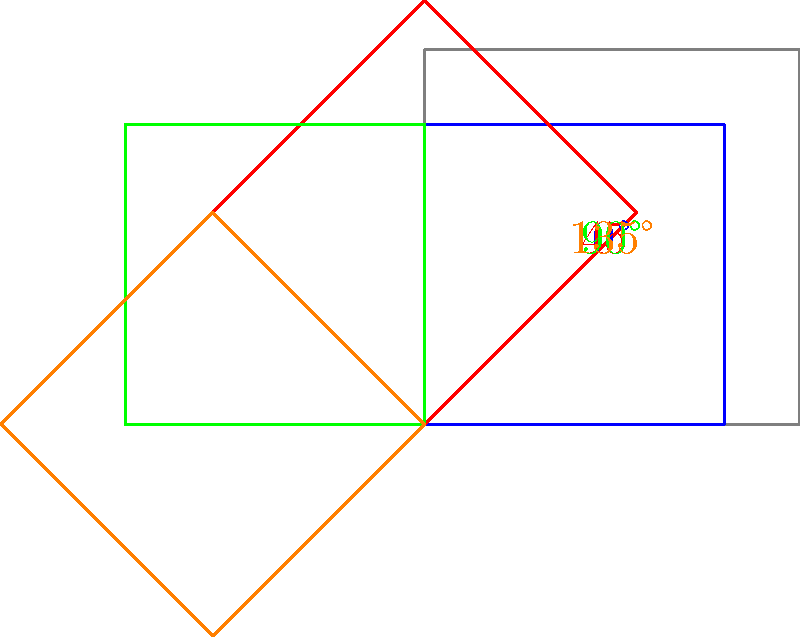You're designing a loading animation for your startup's new mobile app. The animation involves rotating the app icon by different angles. If the icon starts at 0° and rotates counterclockwise, what is the total rotation angle needed to create a smooth animation sequence that includes the positions shown in the diagram (blue, red, green, and orange)? To determine the total rotation angle, we need to follow these steps:

1. Identify the rotation angles for each position:
   - Blue icon: 0° (starting position)
   - Red icon: 45°
   - Green icon: 90°
   - Orange icon: 135°

2. Calculate the difference between the largest and smallest angles:
   $135° - 0° = 135°$

3. However, for a smooth animation, we need to complete a full rotation back to the starting position. This means we need to add the remaining angle to reach 360°:

   $360° - 135° = 225°$

4. Add this remaining angle to our previous calculation:
   $135° + 225° = 360°$

Therefore, the total rotation angle needed for a smooth animation sequence that includes all shown positions and returns to the starting position is 360°.
Answer: 360° 